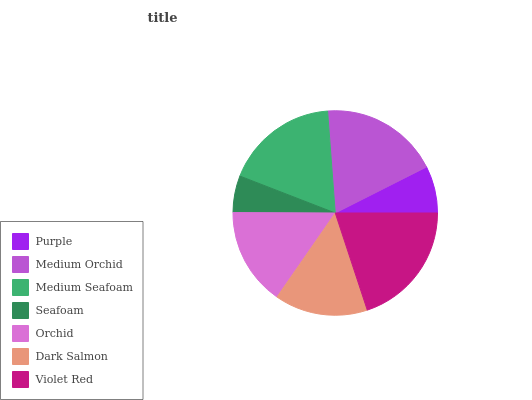Is Seafoam the minimum?
Answer yes or no. Yes. Is Violet Red the maximum?
Answer yes or no. Yes. Is Medium Orchid the minimum?
Answer yes or no. No. Is Medium Orchid the maximum?
Answer yes or no. No. Is Medium Orchid greater than Purple?
Answer yes or no. Yes. Is Purple less than Medium Orchid?
Answer yes or no. Yes. Is Purple greater than Medium Orchid?
Answer yes or no. No. Is Medium Orchid less than Purple?
Answer yes or no. No. Is Orchid the high median?
Answer yes or no. Yes. Is Orchid the low median?
Answer yes or no. Yes. Is Dark Salmon the high median?
Answer yes or no. No. Is Purple the low median?
Answer yes or no. No. 